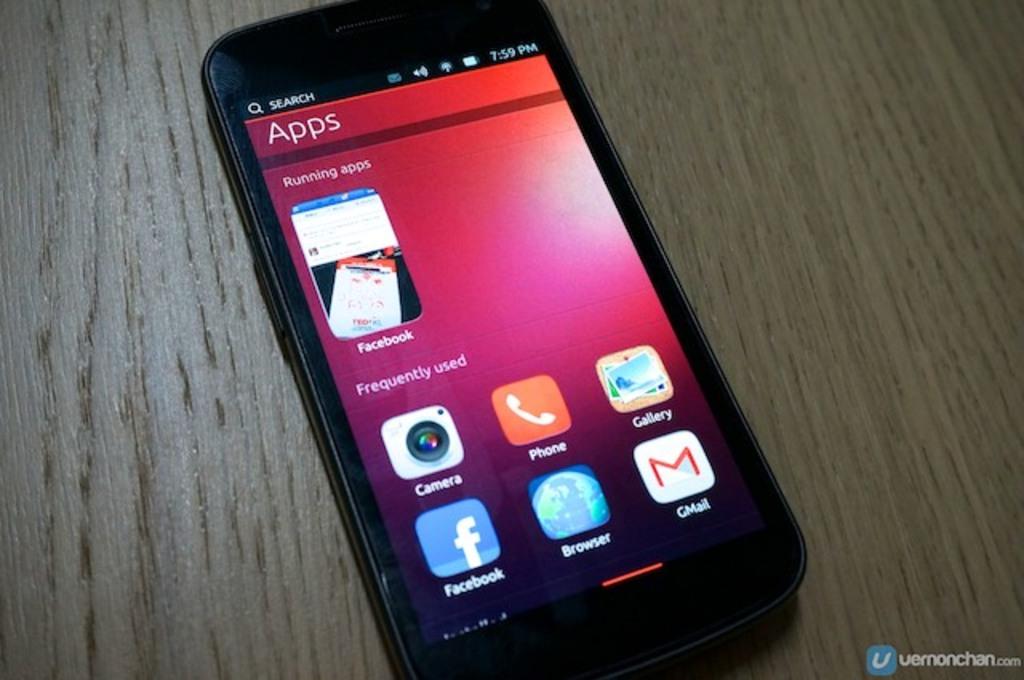What is the bottom left app?
Your response must be concise. Facebook. What is the word at the top of the screen?
Keep it short and to the point. Apps. 